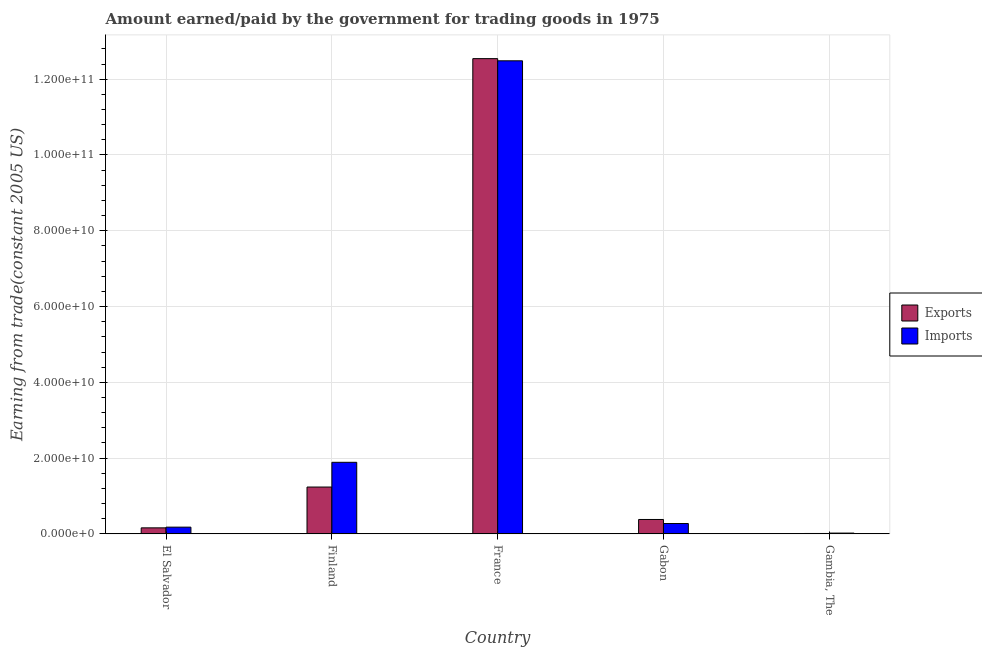How many groups of bars are there?
Make the answer very short. 5. What is the amount earned from exports in Finland?
Provide a succinct answer. 1.24e+1. Across all countries, what is the maximum amount earned from exports?
Your answer should be very brief. 1.25e+11. Across all countries, what is the minimum amount paid for imports?
Ensure brevity in your answer.  2.07e+08. In which country was the amount paid for imports minimum?
Offer a very short reply. Gambia, The. What is the total amount paid for imports in the graph?
Provide a short and direct response. 1.48e+11. What is the difference between the amount earned from exports in Gabon and that in Gambia, The?
Your answer should be very brief. 3.69e+09. What is the difference between the amount earned from exports in Gabon and the amount paid for imports in France?
Make the answer very short. -1.21e+11. What is the average amount paid for imports per country?
Your answer should be compact. 2.97e+1. What is the difference between the amount paid for imports and amount earned from exports in El Salvador?
Provide a short and direct response. 1.86e+08. In how many countries, is the amount earned from exports greater than 104000000000 US$?
Ensure brevity in your answer.  1. What is the ratio of the amount earned from exports in El Salvador to that in Finland?
Provide a succinct answer. 0.13. Is the difference between the amount paid for imports in Finland and Gambia, The greater than the difference between the amount earned from exports in Finland and Gambia, The?
Provide a succinct answer. Yes. What is the difference between the highest and the second highest amount earned from exports?
Offer a terse response. 1.13e+11. What is the difference between the highest and the lowest amount paid for imports?
Your answer should be compact. 1.25e+11. In how many countries, is the amount earned from exports greater than the average amount earned from exports taken over all countries?
Give a very brief answer. 1. What does the 1st bar from the left in Gabon represents?
Make the answer very short. Exports. What does the 1st bar from the right in France represents?
Keep it short and to the point. Imports. How many bars are there?
Your answer should be very brief. 10. What is the difference between two consecutive major ticks on the Y-axis?
Make the answer very short. 2.00e+1. What is the title of the graph?
Give a very brief answer. Amount earned/paid by the government for trading goods in 1975. What is the label or title of the X-axis?
Provide a short and direct response. Country. What is the label or title of the Y-axis?
Give a very brief answer. Earning from trade(constant 2005 US). What is the Earning from trade(constant 2005 US) in Exports in El Salvador?
Your answer should be very brief. 1.59e+09. What is the Earning from trade(constant 2005 US) in Imports in El Salvador?
Your response must be concise. 1.77e+09. What is the Earning from trade(constant 2005 US) of Exports in Finland?
Offer a very short reply. 1.24e+1. What is the Earning from trade(constant 2005 US) of Imports in Finland?
Your answer should be very brief. 1.89e+1. What is the Earning from trade(constant 2005 US) in Exports in France?
Offer a very short reply. 1.25e+11. What is the Earning from trade(constant 2005 US) of Imports in France?
Give a very brief answer. 1.25e+11. What is the Earning from trade(constant 2005 US) in Exports in Gabon?
Ensure brevity in your answer.  3.80e+09. What is the Earning from trade(constant 2005 US) of Imports in Gabon?
Your answer should be very brief. 2.73e+09. What is the Earning from trade(constant 2005 US) in Exports in Gambia, The?
Provide a succinct answer. 1.01e+08. What is the Earning from trade(constant 2005 US) of Imports in Gambia, The?
Your response must be concise. 2.07e+08. Across all countries, what is the maximum Earning from trade(constant 2005 US) in Exports?
Ensure brevity in your answer.  1.25e+11. Across all countries, what is the maximum Earning from trade(constant 2005 US) in Imports?
Offer a very short reply. 1.25e+11. Across all countries, what is the minimum Earning from trade(constant 2005 US) of Exports?
Provide a succinct answer. 1.01e+08. Across all countries, what is the minimum Earning from trade(constant 2005 US) in Imports?
Provide a succinct answer. 2.07e+08. What is the total Earning from trade(constant 2005 US) in Exports in the graph?
Your answer should be very brief. 1.43e+11. What is the total Earning from trade(constant 2005 US) in Imports in the graph?
Provide a short and direct response. 1.48e+11. What is the difference between the Earning from trade(constant 2005 US) in Exports in El Salvador and that in Finland?
Provide a succinct answer. -1.08e+1. What is the difference between the Earning from trade(constant 2005 US) in Imports in El Salvador and that in Finland?
Offer a very short reply. -1.71e+1. What is the difference between the Earning from trade(constant 2005 US) of Exports in El Salvador and that in France?
Your answer should be compact. -1.24e+11. What is the difference between the Earning from trade(constant 2005 US) in Imports in El Salvador and that in France?
Ensure brevity in your answer.  -1.23e+11. What is the difference between the Earning from trade(constant 2005 US) in Exports in El Salvador and that in Gabon?
Your answer should be very brief. -2.21e+09. What is the difference between the Earning from trade(constant 2005 US) of Imports in El Salvador and that in Gabon?
Ensure brevity in your answer.  -9.57e+08. What is the difference between the Earning from trade(constant 2005 US) in Exports in El Salvador and that in Gambia, The?
Give a very brief answer. 1.49e+09. What is the difference between the Earning from trade(constant 2005 US) of Imports in El Salvador and that in Gambia, The?
Keep it short and to the point. 1.57e+09. What is the difference between the Earning from trade(constant 2005 US) of Exports in Finland and that in France?
Provide a short and direct response. -1.13e+11. What is the difference between the Earning from trade(constant 2005 US) in Imports in Finland and that in France?
Your answer should be very brief. -1.06e+11. What is the difference between the Earning from trade(constant 2005 US) in Exports in Finland and that in Gabon?
Your response must be concise. 8.56e+09. What is the difference between the Earning from trade(constant 2005 US) in Imports in Finland and that in Gabon?
Provide a short and direct response. 1.62e+1. What is the difference between the Earning from trade(constant 2005 US) of Exports in Finland and that in Gambia, The?
Offer a very short reply. 1.23e+1. What is the difference between the Earning from trade(constant 2005 US) of Imports in Finland and that in Gambia, The?
Provide a succinct answer. 1.87e+1. What is the difference between the Earning from trade(constant 2005 US) in Exports in France and that in Gabon?
Offer a very short reply. 1.22e+11. What is the difference between the Earning from trade(constant 2005 US) of Imports in France and that in Gabon?
Offer a terse response. 1.22e+11. What is the difference between the Earning from trade(constant 2005 US) in Exports in France and that in Gambia, The?
Offer a very short reply. 1.25e+11. What is the difference between the Earning from trade(constant 2005 US) in Imports in France and that in Gambia, The?
Give a very brief answer. 1.25e+11. What is the difference between the Earning from trade(constant 2005 US) in Exports in Gabon and that in Gambia, The?
Offer a very short reply. 3.69e+09. What is the difference between the Earning from trade(constant 2005 US) in Imports in Gabon and that in Gambia, The?
Make the answer very short. 2.52e+09. What is the difference between the Earning from trade(constant 2005 US) of Exports in El Salvador and the Earning from trade(constant 2005 US) of Imports in Finland?
Ensure brevity in your answer.  -1.73e+1. What is the difference between the Earning from trade(constant 2005 US) in Exports in El Salvador and the Earning from trade(constant 2005 US) in Imports in France?
Offer a terse response. -1.23e+11. What is the difference between the Earning from trade(constant 2005 US) in Exports in El Salvador and the Earning from trade(constant 2005 US) in Imports in Gabon?
Offer a terse response. -1.14e+09. What is the difference between the Earning from trade(constant 2005 US) in Exports in El Salvador and the Earning from trade(constant 2005 US) in Imports in Gambia, The?
Keep it short and to the point. 1.38e+09. What is the difference between the Earning from trade(constant 2005 US) of Exports in Finland and the Earning from trade(constant 2005 US) of Imports in France?
Keep it short and to the point. -1.13e+11. What is the difference between the Earning from trade(constant 2005 US) in Exports in Finland and the Earning from trade(constant 2005 US) in Imports in Gabon?
Keep it short and to the point. 9.63e+09. What is the difference between the Earning from trade(constant 2005 US) in Exports in Finland and the Earning from trade(constant 2005 US) in Imports in Gambia, The?
Your answer should be compact. 1.22e+1. What is the difference between the Earning from trade(constant 2005 US) of Exports in France and the Earning from trade(constant 2005 US) of Imports in Gabon?
Give a very brief answer. 1.23e+11. What is the difference between the Earning from trade(constant 2005 US) of Exports in France and the Earning from trade(constant 2005 US) of Imports in Gambia, The?
Your answer should be very brief. 1.25e+11. What is the difference between the Earning from trade(constant 2005 US) in Exports in Gabon and the Earning from trade(constant 2005 US) in Imports in Gambia, The?
Make the answer very short. 3.59e+09. What is the average Earning from trade(constant 2005 US) of Exports per country?
Provide a short and direct response. 2.87e+1. What is the average Earning from trade(constant 2005 US) in Imports per country?
Keep it short and to the point. 2.97e+1. What is the difference between the Earning from trade(constant 2005 US) in Exports and Earning from trade(constant 2005 US) in Imports in El Salvador?
Offer a terse response. -1.86e+08. What is the difference between the Earning from trade(constant 2005 US) in Exports and Earning from trade(constant 2005 US) in Imports in Finland?
Ensure brevity in your answer.  -6.53e+09. What is the difference between the Earning from trade(constant 2005 US) of Exports and Earning from trade(constant 2005 US) of Imports in France?
Keep it short and to the point. 5.72e+08. What is the difference between the Earning from trade(constant 2005 US) in Exports and Earning from trade(constant 2005 US) in Imports in Gabon?
Your answer should be very brief. 1.07e+09. What is the difference between the Earning from trade(constant 2005 US) in Exports and Earning from trade(constant 2005 US) in Imports in Gambia, The?
Offer a terse response. -1.06e+08. What is the ratio of the Earning from trade(constant 2005 US) of Exports in El Salvador to that in Finland?
Offer a very short reply. 0.13. What is the ratio of the Earning from trade(constant 2005 US) of Imports in El Salvador to that in Finland?
Provide a succinct answer. 0.09. What is the ratio of the Earning from trade(constant 2005 US) of Exports in El Salvador to that in France?
Give a very brief answer. 0.01. What is the ratio of the Earning from trade(constant 2005 US) of Imports in El Salvador to that in France?
Give a very brief answer. 0.01. What is the ratio of the Earning from trade(constant 2005 US) in Exports in El Salvador to that in Gabon?
Your answer should be very brief. 0.42. What is the ratio of the Earning from trade(constant 2005 US) in Imports in El Salvador to that in Gabon?
Provide a short and direct response. 0.65. What is the ratio of the Earning from trade(constant 2005 US) of Exports in El Salvador to that in Gambia, The?
Ensure brevity in your answer.  15.72. What is the ratio of the Earning from trade(constant 2005 US) in Imports in El Salvador to that in Gambia, The?
Give a very brief answer. 8.58. What is the ratio of the Earning from trade(constant 2005 US) in Exports in Finland to that in France?
Keep it short and to the point. 0.1. What is the ratio of the Earning from trade(constant 2005 US) of Imports in Finland to that in France?
Offer a very short reply. 0.15. What is the ratio of the Earning from trade(constant 2005 US) in Exports in Finland to that in Gabon?
Offer a very short reply. 3.26. What is the ratio of the Earning from trade(constant 2005 US) in Imports in Finland to that in Gabon?
Your response must be concise. 6.92. What is the ratio of the Earning from trade(constant 2005 US) in Exports in Finland to that in Gambia, The?
Give a very brief answer. 122.52. What is the ratio of the Earning from trade(constant 2005 US) in Imports in Finland to that in Gambia, The?
Keep it short and to the point. 91.43. What is the ratio of the Earning from trade(constant 2005 US) of Exports in France to that in Gabon?
Your answer should be compact. 33.05. What is the ratio of the Earning from trade(constant 2005 US) in Imports in France to that in Gabon?
Make the answer very short. 45.76. What is the ratio of the Earning from trade(constant 2005 US) in Exports in France to that in Gambia, The?
Offer a very short reply. 1243.71. What is the ratio of the Earning from trade(constant 2005 US) of Imports in France to that in Gambia, The?
Offer a very short reply. 604.49. What is the ratio of the Earning from trade(constant 2005 US) of Exports in Gabon to that in Gambia, The?
Provide a short and direct response. 37.63. What is the ratio of the Earning from trade(constant 2005 US) of Imports in Gabon to that in Gambia, The?
Offer a terse response. 13.21. What is the difference between the highest and the second highest Earning from trade(constant 2005 US) of Exports?
Offer a terse response. 1.13e+11. What is the difference between the highest and the second highest Earning from trade(constant 2005 US) in Imports?
Your response must be concise. 1.06e+11. What is the difference between the highest and the lowest Earning from trade(constant 2005 US) of Exports?
Keep it short and to the point. 1.25e+11. What is the difference between the highest and the lowest Earning from trade(constant 2005 US) of Imports?
Provide a succinct answer. 1.25e+11. 